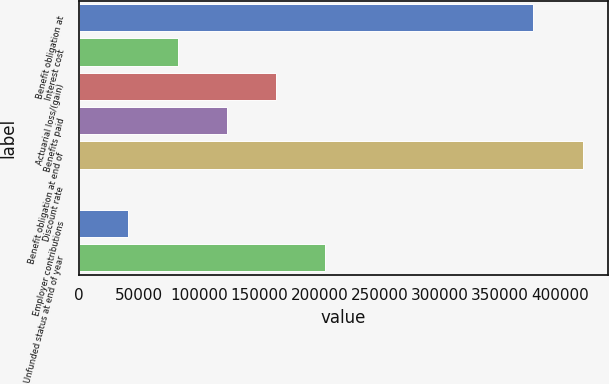Convert chart to OTSL. <chart><loc_0><loc_0><loc_500><loc_500><bar_chart><fcel>Benefit obligation at<fcel>Interest cost<fcel>Actuarial loss/(gain)<fcel>Benefits paid<fcel>Benefit obligation at end of<fcel>Discount rate<fcel>Employer contributions<fcel>Unfunded status at end of year<nl><fcel>378189<fcel>81898.4<fcel>163791<fcel>122845<fcel>419135<fcel>5.49<fcel>40951.9<fcel>204738<nl></chart> 